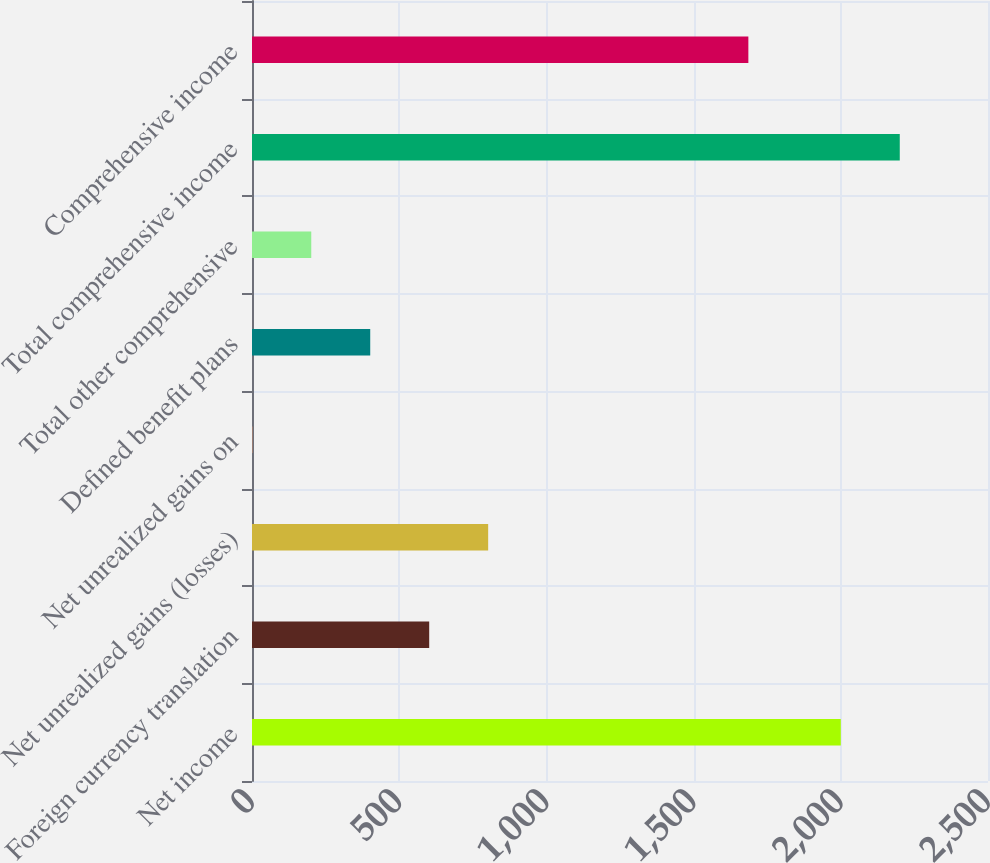Convert chart. <chart><loc_0><loc_0><loc_500><loc_500><bar_chart><fcel>Net income<fcel>Foreign currency translation<fcel>Net unrealized gains (losses)<fcel>Net unrealized gains on<fcel>Defined benefit plans<fcel>Total other comprehensive<fcel>Total comprehensive income<fcel>Comprehensive income<nl><fcel>2000<fcel>601.9<fcel>802.2<fcel>1<fcel>401.6<fcel>201.3<fcel>2200.3<fcel>1686<nl></chart> 